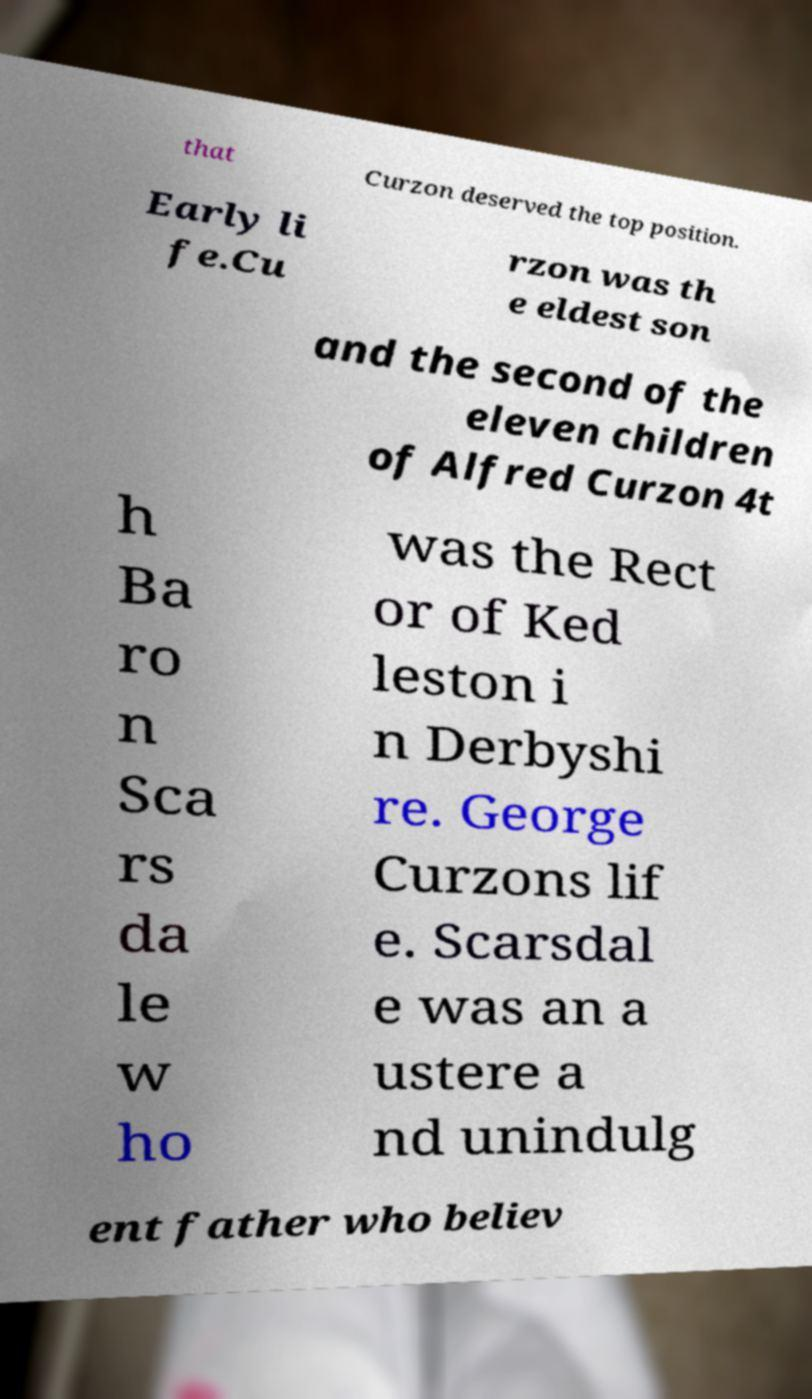Can you accurately transcribe the text from the provided image for me? that Curzon deserved the top position. Early li fe.Cu rzon was th e eldest son and the second of the eleven children of Alfred Curzon 4t h Ba ro n Sca rs da le w ho was the Rect or of Ked leston i n Derbyshi re. George Curzons lif e. Scarsdal e was an a ustere a nd unindulg ent father who believ 